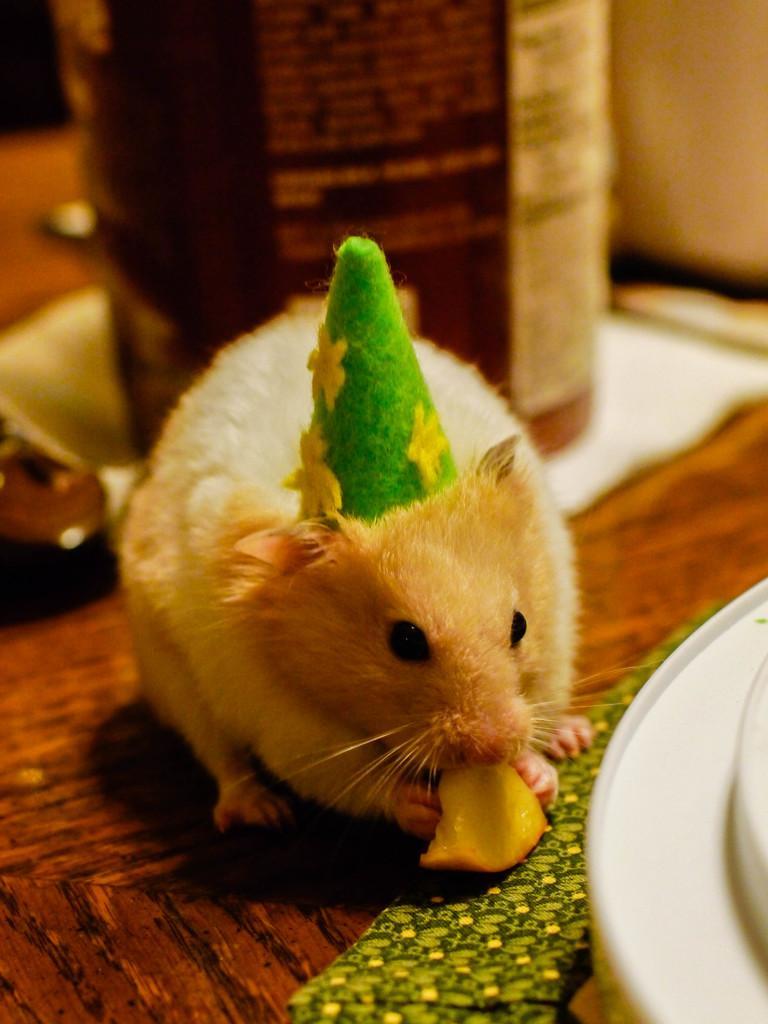Please provide a concise description of this image. In this image a mouse is eating fruit. There is a cap on it. On the table there are plates, bottle and few other things are there. 